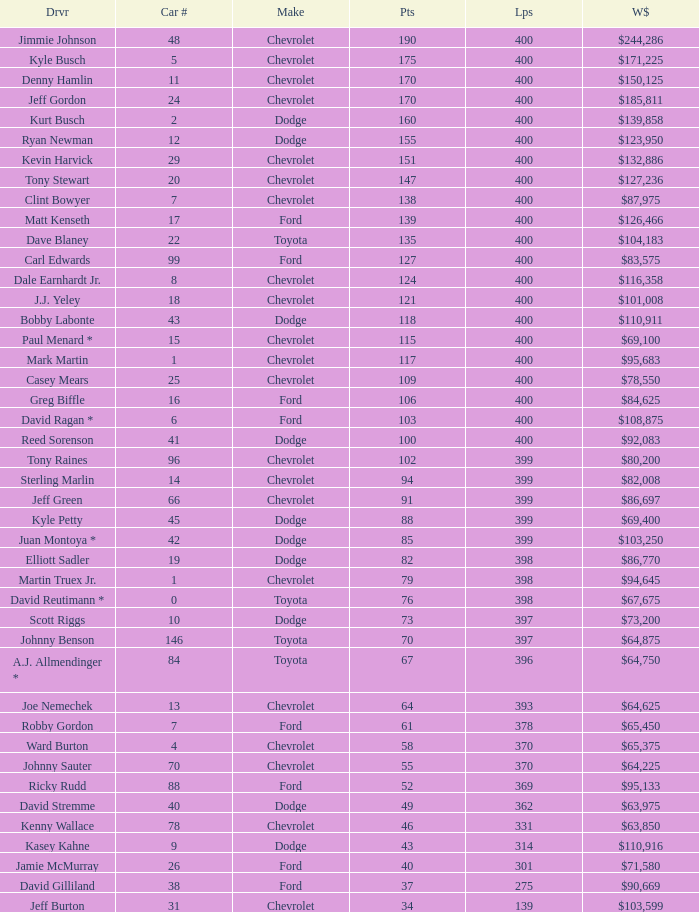Which manufacturer produced car 31? Chevrolet. 